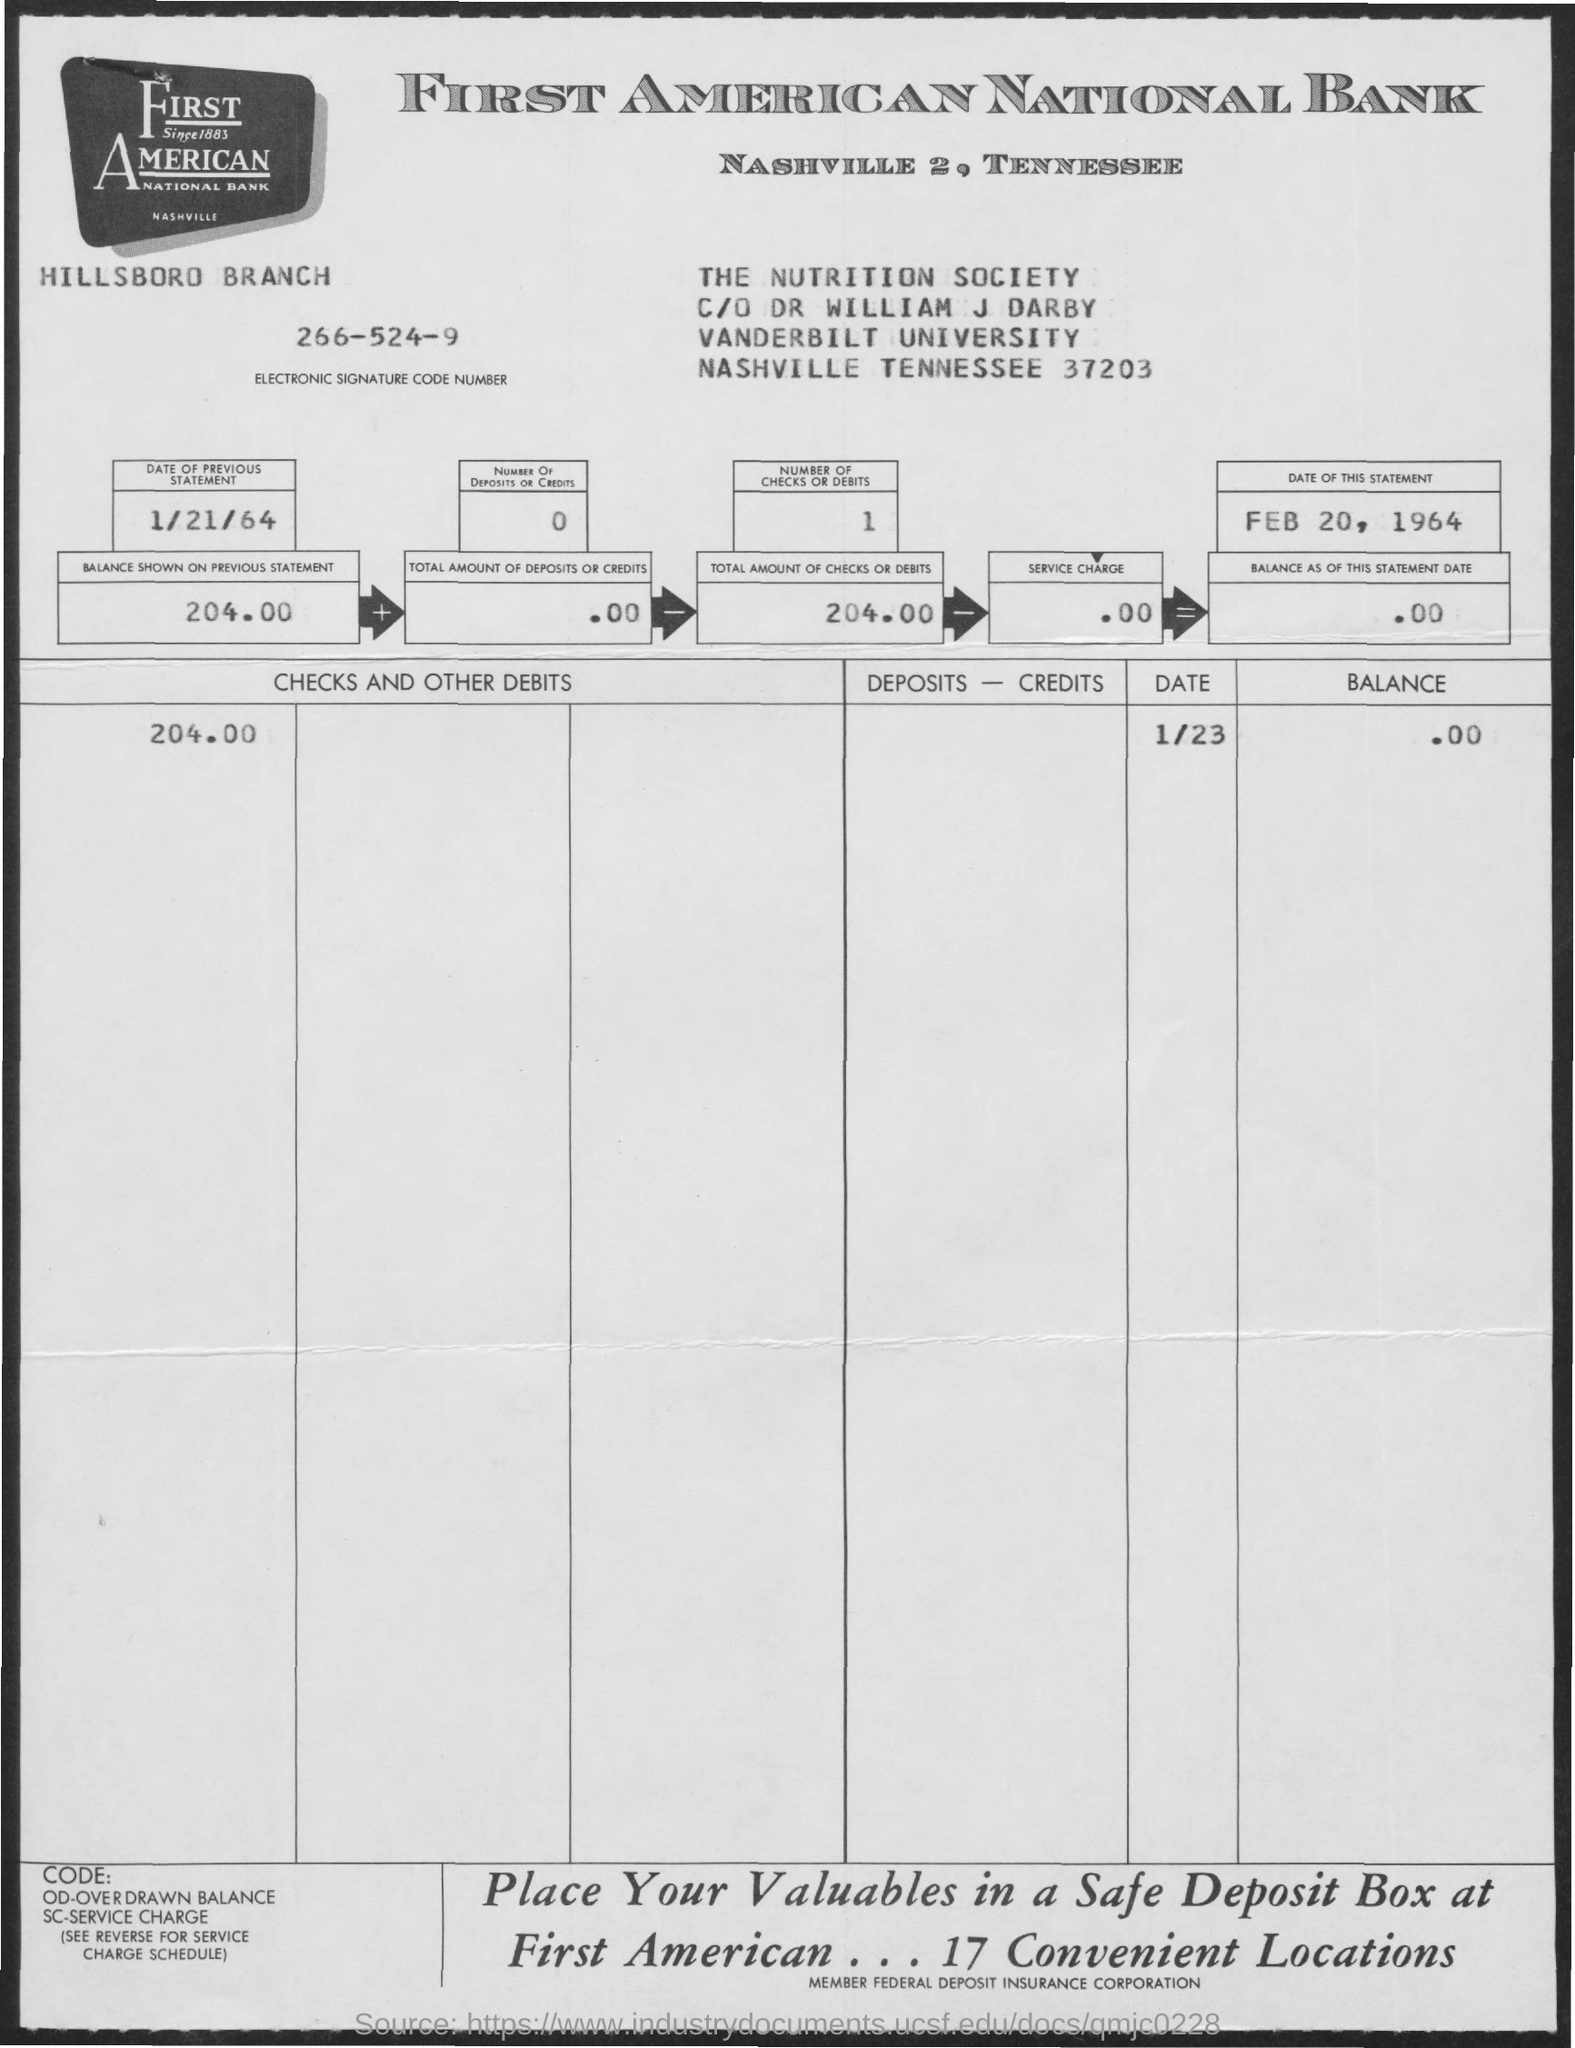What is the Electronic Signature Code Number given in the statement?
 266-524-9 